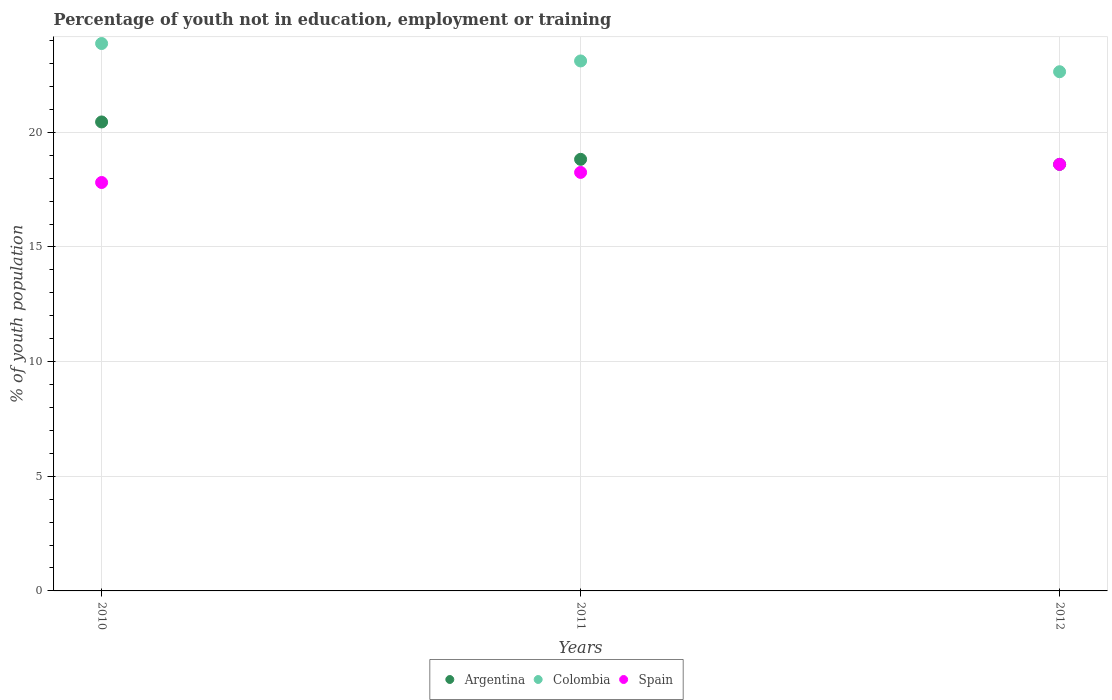How many different coloured dotlines are there?
Make the answer very short. 3. What is the percentage of unemployed youth population in in Argentina in 2010?
Offer a very short reply. 20.45. Across all years, what is the maximum percentage of unemployed youth population in in Argentina?
Make the answer very short. 20.45. Across all years, what is the minimum percentage of unemployed youth population in in Spain?
Provide a short and direct response. 17.81. In which year was the percentage of unemployed youth population in in Colombia maximum?
Keep it short and to the point. 2010. In which year was the percentage of unemployed youth population in in Colombia minimum?
Make the answer very short. 2012. What is the total percentage of unemployed youth population in in Colombia in the graph?
Keep it short and to the point. 69.62. What is the difference between the percentage of unemployed youth population in in Spain in 2010 and that in 2012?
Offer a terse response. -0.79. What is the difference between the percentage of unemployed youth population in in Colombia in 2010 and the percentage of unemployed youth population in in Spain in 2012?
Ensure brevity in your answer.  5.27. What is the average percentage of unemployed youth population in in Argentina per year?
Offer a terse response. 19.29. In the year 2012, what is the difference between the percentage of unemployed youth population in in Spain and percentage of unemployed youth population in in Colombia?
Your answer should be compact. -4.04. In how many years, is the percentage of unemployed youth population in in Colombia greater than 20 %?
Keep it short and to the point. 3. What is the ratio of the percentage of unemployed youth population in in Spain in 2011 to that in 2012?
Offer a terse response. 0.98. Is the difference between the percentage of unemployed youth population in in Spain in 2011 and 2012 greater than the difference between the percentage of unemployed youth population in in Colombia in 2011 and 2012?
Your answer should be very brief. No. What is the difference between the highest and the second highest percentage of unemployed youth population in in Spain?
Ensure brevity in your answer.  0.35. What is the difference between the highest and the lowest percentage of unemployed youth population in in Argentina?
Ensure brevity in your answer.  1.85. Is it the case that in every year, the sum of the percentage of unemployed youth population in in Argentina and percentage of unemployed youth population in in Spain  is greater than the percentage of unemployed youth population in in Colombia?
Offer a terse response. Yes. Is the percentage of unemployed youth population in in Argentina strictly greater than the percentage of unemployed youth population in in Spain over the years?
Give a very brief answer. No. Is the percentage of unemployed youth population in in Argentina strictly less than the percentage of unemployed youth population in in Colombia over the years?
Ensure brevity in your answer.  Yes. How many dotlines are there?
Provide a short and direct response. 3. What is the difference between two consecutive major ticks on the Y-axis?
Provide a short and direct response. 5. Are the values on the major ticks of Y-axis written in scientific E-notation?
Ensure brevity in your answer.  No. Where does the legend appear in the graph?
Your response must be concise. Bottom center. How many legend labels are there?
Give a very brief answer. 3. How are the legend labels stacked?
Your answer should be very brief. Horizontal. What is the title of the graph?
Ensure brevity in your answer.  Percentage of youth not in education, employment or training. Does "Sint Maarten (Dutch part)" appear as one of the legend labels in the graph?
Your answer should be compact. No. What is the label or title of the Y-axis?
Your answer should be very brief. % of youth population. What is the % of youth population of Argentina in 2010?
Your answer should be very brief. 20.45. What is the % of youth population of Colombia in 2010?
Your answer should be compact. 23.87. What is the % of youth population in Spain in 2010?
Provide a succinct answer. 17.81. What is the % of youth population in Argentina in 2011?
Provide a succinct answer. 18.82. What is the % of youth population in Colombia in 2011?
Give a very brief answer. 23.11. What is the % of youth population in Spain in 2011?
Offer a terse response. 18.25. What is the % of youth population of Argentina in 2012?
Provide a short and direct response. 18.6. What is the % of youth population in Colombia in 2012?
Offer a terse response. 22.64. What is the % of youth population in Spain in 2012?
Provide a short and direct response. 18.6. Across all years, what is the maximum % of youth population of Argentina?
Give a very brief answer. 20.45. Across all years, what is the maximum % of youth population in Colombia?
Offer a very short reply. 23.87. Across all years, what is the maximum % of youth population in Spain?
Make the answer very short. 18.6. Across all years, what is the minimum % of youth population in Argentina?
Provide a short and direct response. 18.6. Across all years, what is the minimum % of youth population in Colombia?
Make the answer very short. 22.64. Across all years, what is the minimum % of youth population in Spain?
Ensure brevity in your answer.  17.81. What is the total % of youth population in Argentina in the graph?
Provide a short and direct response. 57.87. What is the total % of youth population in Colombia in the graph?
Give a very brief answer. 69.62. What is the total % of youth population of Spain in the graph?
Offer a very short reply. 54.66. What is the difference between the % of youth population in Argentina in 2010 and that in 2011?
Your answer should be very brief. 1.63. What is the difference between the % of youth population of Colombia in 2010 and that in 2011?
Offer a terse response. 0.76. What is the difference between the % of youth population of Spain in 2010 and that in 2011?
Make the answer very short. -0.44. What is the difference between the % of youth population in Argentina in 2010 and that in 2012?
Offer a terse response. 1.85. What is the difference between the % of youth population in Colombia in 2010 and that in 2012?
Your response must be concise. 1.23. What is the difference between the % of youth population in Spain in 2010 and that in 2012?
Provide a succinct answer. -0.79. What is the difference between the % of youth population in Argentina in 2011 and that in 2012?
Your answer should be compact. 0.22. What is the difference between the % of youth population in Colombia in 2011 and that in 2012?
Offer a very short reply. 0.47. What is the difference between the % of youth population of Spain in 2011 and that in 2012?
Give a very brief answer. -0.35. What is the difference between the % of youth population of Argentina in 2010 and the % of youth population of Colombia in 2011?
Your answer should be very brief. -2.66. What is the difference between the % of youth population of Argentina in 2010 and the % of youth population of Spain in 2011?
Provide a short and direct response. 2.2. What is the difference between the % of youth population of Colombia in 2010 and the % of youth population of Spain in 2011?
Provide a succinct answer. 5.62. What is the difference between the % of youth population of Argentina in 2010 and the % of youth population of Colombia in 2012?
Provide a short and direct response. -2.19. What is the difference between the % of youth population in Argentina in 2010 and the % of youth population in Spain in 2012?
Provide a succinct answer. 1.85. What is the difference between the % of youth population in Colombia in 2010 and the % of youth population in Spain in 2012?
Make the answer very short. 5.27. What is the difference between the % of youth population of Argentina in 2011 and the % of youth population of Colombia in 2012?
Your answer should be compact. -3.82. What is the difference between the % of youth population of Argentina in 2011 and the % of youth population of Spain in 2012?
Offer a terse response. 0.22. What is the difference between the % of youth population in Colombia in 2011 and the % of youth population in Spain in 2012?
Make the answer very short. 4.51. What is the average % of youth population of Argentina per year?
Your answer should be compact. 19.29. What is the average % of youth population in Colombia per year?
Make the answer very short. 23.21. What is the average % of youth population of Spain per year?
Offer a very short reply. 18.22. In the year 2010, what is the difference between the % of youth population of Argentina and % of youth population of Colombia?
Offer a very short reply. -3.42. In the year 2010, what is the difference between the % of youth population of Argentina and % of youth population of Spain?
Provide a succinct answer. 2.64. In the year 2010, what is the difference between the % of youth population in Colombia and % of youth population in Spain?
Provide a succinct answer. 6.06. In the year 2011, what is the difference between the % of youth population in Argentina and % of youth population in Colombia?
Make the answer very short. -4.29. In the year 2011, what is the difference between the % of youth population in Argentina and % of youth population in Spain?
Your answer should be very brief. 0.57. In the year 2011, what is the difference between the % of youth population in Colombia and % of youth population in Spain?
Your answer should be very brief. 4.86. In the year 2012, what is the difference between the % of youth population of Argentina and % of youth population of Colombia?
Offer a very short reply. -4.04. In the year 2012, what is the difference between the % of youth population of Colombia and % of youth population of Spain?
Your answer should be compact. 4.04. What is the ratio of the % of youth population in Argentina in 2010 to that in 2011?
Ensure brevity in your answer.  1.09. What is the ratio of the % of youth population in Colombia in 2010 to that in 2011?
Give a very brief answer. 1.03. What is the ratio of the % of youth population of Spain in 2010 to that in 2011?
Keep it short and to the point. 0.98. What is the ratio of the % of youth population of Argentina in 2010 to that in 2012?
Ensure brevity in your answer.  1.1. What is the ratio of the % of youth population of Colombia in 2010 to that in 2012?
Make the answer very short. 1.05. What is the ratio of the % of youth population of Spain in 2010 to that in 2012?
Your answer should be very brief. 0.96. What is the ratio of the % of youth population in Argentina in 2011 to that in 2012?
Make the answer very short. 1.01. What is the ratio of the % of youth population in Colombia in 2011 to that in 2012?
Your answer should be compact. 1.02. What is the ratio of the % of youth population of Spain in 2011 to that in 2012?
Provide a succinct answer. 0.98. What is the difference between the highest and the second highest % of youth population in Argentina?
Provide a short and direct response. 1.63. What is the difference between the highest and the second highest % of youth population of Colombia?
Your response must be concise. 0.76. What is the difference between the highest and the second highest % of youth population of Spain?
Make the answer very short. 0.35. What is the difference between the highest and the lowest % of youth population of Argentina?
Your response must be concise. 1.85. What is the difference between the highest and the lowest % of youth population of Colombia?
Offer a very short reply. 1.23. What is the difference between the highest and the lowest % of youth population in Spain?
Provide a succinct answer. 0.79. 